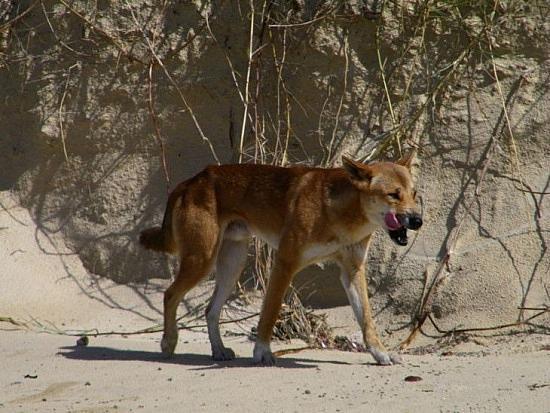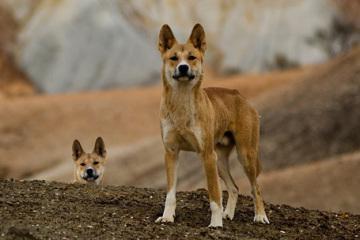The first image is the image on the left, the second image is the image on the right. Assess this claim about the two images: "The combined images include at least two dingo pups and at least one adult dingo.". Correct or not? Answer yes or no. No. The first image is the image on the left, the second image is the image on the right. Evaluate the accuracy of this statement regarding the images: "A brown dog with large pointy ears is looking directly forward.". Is it true? Answer yes or no. Yes. 